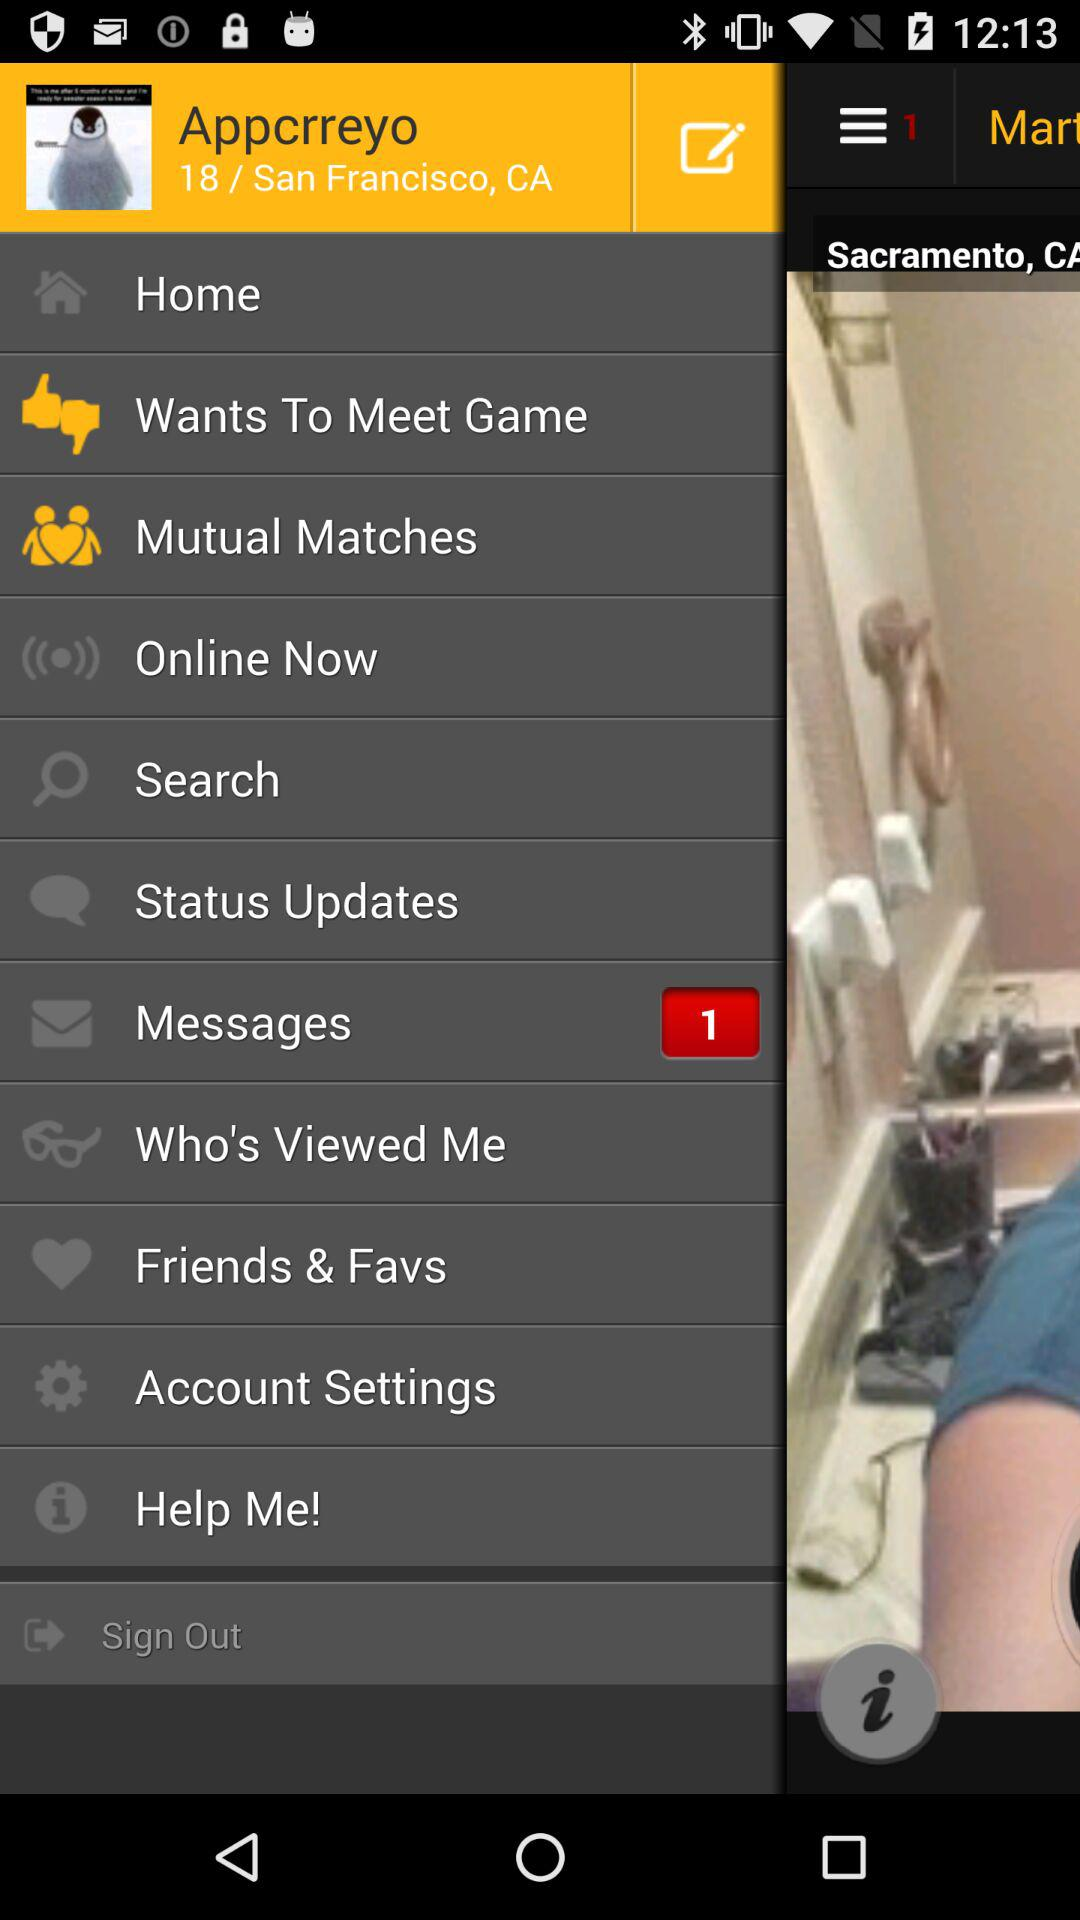What is the location of the user? The location of the user is San Francisco, CA. 